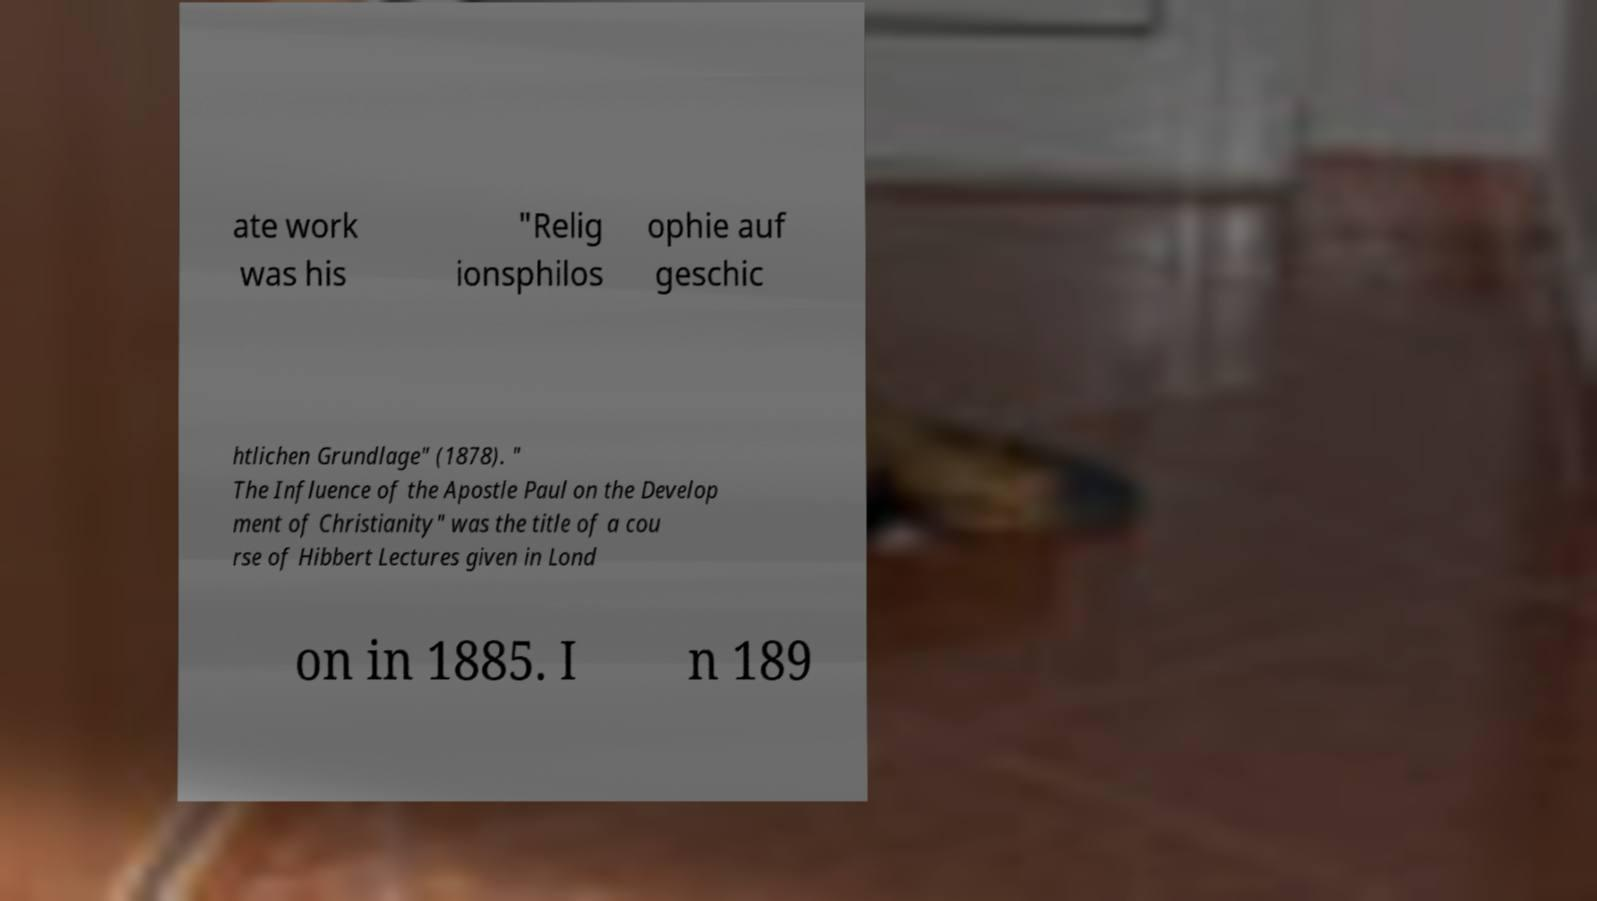Can you accurately transcribe the text from the provided image for me? ate work was his "Relig ionsphilos ophie auf geschic htlichen Grundlage" (1878). " The Influence of the Apostle Paul on the Develop ment of Christianity" was the title of a cou rse of Hibbert Lectures given in Lond on in 1885. I n 189 